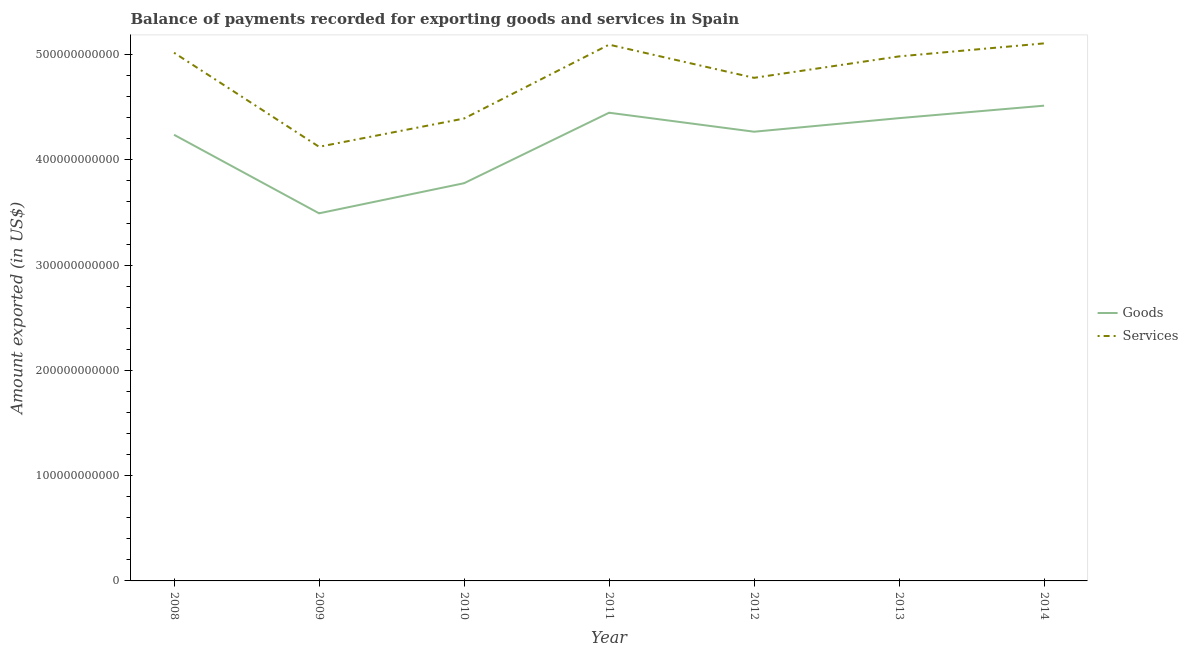Does the line corresponding to amount of services exported intersect with the line corresponding to amount of goods exported?
Your answer should be compact. No. Is the number of lines equal to the number of legend labels?
Give a very brief answer. Yes. What is the amount of goods exported in 2010?
Provide a short and direct response. 3.78e+11. Across all years, what is the maximum amount of services exported?
Provide a short and direct response. 5.11e+11. Across all years, what is the minimum amount of services exported?
Offer a terse response. 4.12e+11. In which year was the amount of services exported maximum?
Your response must be concise. 2014. What is the total amount of services exported in the graph?
Offer a terse response. 3.35e+12. What is the difference between the amount of goods exported in 2011 and that in 2014?
Offer a terse response. -6.69e+09. What is the difference between the amount of services exported in 2014 and the amount of goods exported in 2008?
Your response must be concise. 8.68e+1. What is the average amount of services exported per year?
Provide a succinct answer. 4.79e+11. In the year 2013, what is the difference between the amount of services exported and amount of goods exported?
Keep it short and to the point. 5.87e+1. In how many years, is the amount of services exported greater than 100000000000 US$?
Your answer should be very brief. 7. What is the ratio of the amount of goods exported in 2011 to that in 2012?
Your answer should be very brief. 1.04. Is the difference between the amount of services exported in 2010 and 2011 greater than the difference between the amount of goods exported in 2010 and 2011?
Keep it short and to the point. No. What is the difference between the highest and the second highest amount of goods exported?
Give a very brief answer. 6.69e+09. What is the difference between the highest and the lowest amount of services exported?
Provide a short and direct response. 9.82e+1. Is the sum of the amount of goods exported in 2008 and 2011 greater than the maximum amount of services exported across all years?
Provide a short and direct response. Yes. How many years are there in the graph?
Your answer should be very brief. 7. What is the difference between two consecutive major ticks on the Y-axis?
Your answer should be very brief. 1.00e+11. Does the graph contain any zero values?
Offer a terse response. No. Where does the legend appear in the graph?
Your answer should be compact. Center right. What is the title of the graph?
Your answer should be very brief. Balance of payments recorded for exporting goods and services in Spain. What is the label or title of the X-axis?
Offer a terse response. Year. What is the label or title of the Y-axis?
Provide a short and direct response. Amount exported (in US$). What is the Amount exported (in US$) in Goods in 2008?
Keep it short and to the point. 4.24e+11. What is the Amount exported (in US$) of Services in 2008?
Your response must be concise. 5.02e+11. What is the Amount exported (in US$) in Goods in 2009?
Your answer should be very brief. 3.49e+11. What is the Amount exported (in US$) in Services in 2009?
Keep it short and to the point. 4.12e+11. What is the Amount exported (in US$) of Goods in 2010?
Your response must be concise. 3.78e+11. What is the Amount exported (in US$) of Services in 2010?
Ensure brevity in your answer.  4.39e+11. What is the Amount exported (in US$) in Goods in 2011?
Provide a short and direct response. 4.45e+11. What is the Amount exported (in US$) in Services in 2011?
Your answer should be very brief. 5.09e+11. What is the Amount exported (in US$) of Goods in 2012?
Your answer should be very brief. 4.27e+11. What is the Amount exported (in US$) in Services in 2012?
Offer a terse response. 4.78e+11. What is the Amount exported (in US$) of Goods in 2013?
Make the answer very short. 4.40e+11. What is the Amount exported (in US$) of Services in 2013?
Keep it short and to the point. 4.98e+11. What is the Amount exported (in US$) of Goods in 2014?
Your answer should be compact. 4.52e+11. What is the Amount exported (in US$) of Services in 2014?
Give a very brief answer. 5.11e+11. Across all years, what is the maximum Amount exported (in US$) of Goods?
Provide a short and direct response. 4.52e+11. Across all years, what is the maximum Amount exported (in US$) of Services?
Your answer should be very brief. 5.11e+11. Across all years, what is the minimum Amount exported (in US$) of Goods?
Give a very brief answer. 3.49e+11. Across all years, what is the minimum Amount exported (in US$) in Services?
Your answer should be very brief. 4.12e+11. What is the total Amount exported (in US$) of Goods in the graph?
Ensure brevity in your answer.  2.91e+12. What is the total Amount exported (in US$) of Services in the graph?
Your answer should be very brief. 3.35e+12. What is the difference between the Amount exported (in US$) of Goods in 2008 and that in 2009?
Keep it short and to the point. 7.46e+1. What is the difference between the Amount exported (in US$) in Services in 2008 and that in 2009?
Your answer should be very brief. 8.94e+1. What is the difference between the Amount exported (in US$) in Goods in 2008 and that in 2010?
Give a very brief answer. 4.60e+1. What is the difference between the Amount exported (in US$) of Services in 2008 and that in 2010?
Keep it short and to the point. 6.25e+1. What is the difference between the Amount exported (in US$) of Goods in 2008 and that in 2011?
Offer a very short reply. -2.10e+1. What is the difference between the Amount exported (in US$) in Services in 2008 and that in 2011?
Give a very brief answer. -7.68e+09. What is the difference between the Amount exported (in US$) of Goods in 2008 and that in 2012?
Provide a succinct answer. -2.91e+09. What is the difference between the Amount exported (in US$) of Services in 2008 and that in 2012?
Your response must be concise. 2.39e+1. What is the difference between the Amount exported (in US$) in Goods in 2008 and that in 2013?
Keep it short and to the point. -1.58e+1. What is the difference between the Amount exported (in US$) of Services in 2008 and that in 2013?
Provide a succinct answer. 3.48e+09. What is the difference between the Amount exported (in US$) in Goods in 2008 and that in 2014?
Provide a succinct answer. -2.76e+1. What is the difference between the Amount exported (in US$) in Services in 2008 and that in 2014?
Give a very brief answer. -8.88e+09. What is the difference between the Amount exported (in US$) of Goods in 2009 and that in 2010?
Offer a very short reply. -2.86e+1. What is the difference between the Amount exported (in US$) of Services in 2009 and that in 2010?
Make the answer very short. -2.69e+1. What is the difference between the Amount exported (in US$) of Goods in 2009 and that in 2011?
Give a very brief answer. -9.56e+1. What is the difference between the Amount exported (in US$) in Services in 2009 and that in 2011?
Your answer should be very brief. -9.70e+1. What is the difference between the Amount exported (in US$) in Goods in 2009 and that in 2012?
Give a very brief answer. -7.75e+1. What is the difference between the Amount exported (in US$) of Services in 2009 and that in 2012?
Offer a very short reply. -6.55e+1. What is the difference between the Amount exported (in US$) in Goods in 2009 and that in 2013?
Keep it short and to the point. -9.04e+1. What is the difference between the Amount exported (in US$) in Services in 2009 and that in 2013?
Keep it short and to the point. -8.59e+1. What is the difference between the Amount exported (in US$) in Goods in 2009 and that in 2014?
Your answer should be very brief. -1.02e+11. What is the difference between the Amount exported (in US$) of Services in 2009 and that in 2014?
Offer a terse response. -9.82e+1. What is the difference between the Amount exported (in US$) of Goods in 2010 and that in 2011?
Ensure brevity in your answer.  -6.70e+1. What is the difference between the Amount exported (in US$) of Services in 2010 and that in 2011?
Your response must be concise. -7.02e+1. What is the difference between the Amount exported (in US$) of Goods in 2010 and that in 2012?
Offer a terse response. -4.89e+1. What is the difference between the Amount exported (in US$) of Services in 2010 and that in 2012?
Keep it short and to the point. -3.86e+1. What is the difference between the Amount exported (in US$) of Goods in 2010 and that in 2013?
Your response must be concise. -6.18e+1. What is the difference between the Amount exported (in US$) in Services in 2010 and that in 2013?
Your answer should be compact. -5.90e+1. What is the difference between the Amount exported (in US$) of Goods in 2010 and that in 2014?
Ensure brevity in your answer.  -7.37e+1. What is the difference between the Amount exported (in US$) of Services in 2010 and that in 2014?
Offer a terse response. -7.14e+1. What is the difference between the Amount exported (in US$) of Goods in 2011 and that in 2012?
Make the answer very short. 1.80e+1. What is the difference between the Amount exported (in US$) in Services in 2011 and that in 2012?
Offer a very short reply. 3.15e+1. What is the difference between the Amount exported (in US$) in Goods in 2011 and that in 2013?
Offer a terse response. 5.15e+09. What is the difference between the Amount exported (in US$) of Services in 2011 and that in 2013?
Your answer should be very brief. 1.12e+1. What is the difference between the Amount exported (in US$) in Goods in 2011 and that in 2014?
Provide a succinct answer. -6.69e+09. What is the difference between the Amount exported (in US$) in Services in 2011 and that in 2014?
Your response must be concise. -1.21e+09. What is the difference between the Amount exported (in US$) in Goods in 2012 and that in 2013?
Your answer should be compact. -1.29e+1. What is the difference between the Amount exported (in US$) in Services in 2012 and that in 2013?
Your answer should be very brief. -2.04e+1. What is the difference between the Amount exported (in US$) of Goods in 2012 and that in 2014?
Give a very brief answer. -2.47e+1. What is the difference between the Amount exported (in US$) of Services in 2012 and that in 2014?
Your answer should be compact. -3.27e+1. What is the difference between the Amount exported (in US$) in Goods in 2013 and that in 2014?
Offer a very short reply. -1.18e+1. What is the difference between the Amount exported (in US$) in Services in 2013 and that in 2014?
Your answer should be compact. -1.24e+1. What is the difference between the Amount exported (in US$) in Goods in 2008 and the Amount exported (in US$) in Services in 2009?
Your answer should be compact. 1.14e+1. What is the difference between the Amount exported (in US$) in Goods in 2008 and the Amount exported (in US$) in Services in 2010?
Your answer should be compact. -1.54e+1. What is the difference between the Amount exported (in US$) of Goods in 2008 and the Amount exported (in US$) of Services in 2011?
Keep it short and to the point. -8.56e+1. What is the difference between the Amount exported (in US$) in Goods in 2008 and the Amount exported (in US$) in Services in 2012?
Make the answer very short. -5.41e+1. What is the difference between the Amount exported (in US$) in Goods in 2008 and the Amount exported (in US$) in Services in 2013?
Your answer should be compact. -7.45e+1. What is the difference between the Amount exported (in US$) in Goods in 2008 and the Amount exported (in US$) in Services in 2014?
Make the answer very short. -8.68e+1. What is the difference between the Amount exported (in US$) in Goods in 2009 and the Amount exported (in US$) in Services in 2010?
Give a very brief answer. -9.01e+1. What is the difference between the Amount exported (in US$) of Goods in 2009 and the Amount exported (in US$) of Services in 2011?
Keep it short and to the point. -1.60e+11. What is the difference between the Amount exported (in US$) in Goods in 2009 and the Amount exported (in US$) in Services in 2012?
Provide a short and direct response. -1.29e+11. What is the difference between the Amount exported (in US$) of Goods in 2009 and the Amount exported (in US$) of Services in 2013?
Provide a succinct answer. -1.49e+11. What is the difference between the Amount exported (in US$) of Goods in 2009 and the Amount exported (in US$) of Services in 2014?
Your answer should be compact. -1.61e+11. What is the difference between the Amount exported (in US$) of Goods in 2010 and the Amount exported (in US$) of Services in 2011?
Keep it short and to the point. -1.32e+11. What is the difference between the Amount exported (in US$) in Goods in 2010 and the Amount exported (in US$) in Services in 2012?
Provide a succinct answer. -1.00e+11. What is the difference between the Amount exported (in US$) in Goods in 2010 and the Amount exported (in US$) in Services in 2013?
Your response must be concise. -1.20e+11. What is the difference between the Amount exported (in US$) of Goods in 2010 and the Amount exported (in US$) of Services in 2014?
Your answer should be very brief. -1.33e+11. What is the difference between the Amount exported (in US$) of Goods in 2011 and the Amount exported (in US$) of Services in 2012?
Ensure brevity in your answer.  -3.31e+1. What is the difference between the Amount exported (in US$) of Goods in 2011 and the Amount exported (in US$) of Services in 2013?
Your answer should be compact. -5.35e+1. What is the difference between the Amount exported (in US$) in Goods in 2011 and the Amount exported (in US$) in Services in 2014?
Make the answer very short. -6.59e+1. What is the difference between the Amount exported (in US$) of Goods in 2012 and the Amount exported (in US$) of Services in 2013?
Your answer should be very brief. -7.16e+1. What is the difference between the Amount exported (in US$) in Goods in 2012 and the Amount exported (in US$) in Services in 2014?
Your response must be concise. -8.39e+1. What is the difference between the Amount exported (in US$) of Goods in 2013 and the Amount exported (in US$) of Services in 2014?
Give a very brief answer. -7.10e+1. What is the average Amount exported (in US$) in Goods per year?
Offer a terse response. 4.16e+11. What is the average Amount exported (in US$) of Services per year?
Give a very brief answer. 4.79e+11. In the year 2008, what is the difference between the Amount exported (in US$) in Goods and Amount exported (in US$) in Services?
Make the answer very short. -7.80e+1. In the year 2009, what is the difference between the Amount exported (in US$) of Goods and Amount exported (in US$) of Services?
Keep it short and to the point. -6.32e+1. In the year 2010, what is the difference between the Amount exported (in US$) in Goods and Amount exported (in US$) in Services?
Ensure brevity in your answer.  -6.15e+1. In the year 2011, what is the difference between the Amount exported (in US$) in Goods and Amount exported (in US$) in Services?
Keep it short and to the point. -6.47e+1. In the year 2012, what is the difference between the Amount exported (in US$) in Goods and Amount exported (in US$) in Services?
Your answer should be compact. -5.12e+1. In the year 2013, what is the difference between the Amount exported (in US$) in Goods and Amount exported (in US$) in Services?
Your answer should be compact. -5.87e+1. In the year 2014, what is the difference between the Amount exported (in US$) of Goods and Amount exported (in US$) of Services?
Your answer should be very brief. -5.92e+1. What is the ratio of the Amount exported (in US$) in Goods in 2008 to that in 2009?
Offer a very short reply. 1.21. What is the ratio of the Amount exported (in US$) of Services in 2008 to that in 2009?
Your answer should be compact. 1.22. What is the ratio of the Amount exported (in US$) of Goods in 2008 to that in 2010?
Your response must be concise. 1.12. What is the ratio of the Amount exported (in US$) in Services in 2008 to that in 2010?
Your response must be concise. 1.14. What is the ratio of the Amount exported (in US$) in Goods in 2008 to that in 2011?
Your response must be concise. 0.95. What is the ratio of the Amount exported (in US$) in Services in 2008 to that in 2011?
Your answer should be very brief. 0.98. What is the ratio of the Amount exported (in US$) in Goods in 2008 to that in 2012?
Your answer should be very brief. 0.99. What is the ratio of the Amount exported (in US$) in Services in 2008 to that in 2012?
Provide a short and direct response. 1.05. What is the ratio of the Amount exported (in US$) in Goods in 2008 to that in 2013?
Offer a very short reply. 0.96. What is the ratio of the Amount exported (in US$) in Services in 2008 to that in 2013?
Offer a very short reply. 1.01. What is the ratio of the Amount exported (in US$) of Goods in 2008 to that in 2014?
Make the answer very short. 0.94. What is the ratio of the Amount exported (in US$) in Services in 2008 to that in 2014?
Keep it short and to the point. 0.98. What is the ratio of the Amount exported (in US$) in Goods in 2009 to that in 2010?
Your answer should be very brief. 0.92. What is the ratio of the Amount exported (in US$) in Services in 2009 to that in 2010?
Give a very brief answer. 0.94. What is the ratio of the Amount exported (in US$) of Goods in 2009 to that in 2011?
Provide a short and direct response. 0.79. What is the ratio of the Amount exported (in US$) in Services in 2009 to that in 2011?
Keep it short and to the point. 0.81. What is the ratio of the Amount exported (in US$) in Goods in 2009 to that in 2012?
Provide a short and direct response. 0.82. What is the ratio of the Amount exported (in US$) of Services in 2009 to that in 2012?
Your answer should be compact. 0.86. What is the ratio of the Amount exported (in US$) in Goods in 2009 to that in 2013?
Your answer should be very brief. 0.79. What is the ratio of the Amount exported (in US$) of Services in 2009 to that in 2013?
Offer a terse response. 0.83. What is the ratio of the Amount exported (in US$) in Goods in 2009 to that in 2014?
Provide a succinct answer. 0.77. What is the ratio of the Amount exported (in US$) of Services in 2009 to that in 2014?
Keep it short and to the point. 0.81. What is the ratio of the Amount exported (in US$) in Goods in 2010 to that in 2011?
Provide a succinct answer. 0.85. What is the ratio of the Amount exported (in US$) of Services in 2010 to that in 2011?
Keep it short and to the point. 0.86. What is the ratio of the Amount exported (in US$) of Goods in 2010 to that in 2012?
Your response must be concise. 0.89. What is the ratio of the Amount exported (in US$) in Services in 2010 to that in 2012?
Give a very brief answer. 0.92. What is the ratio of the Amount exported (in US$) in Goods in 2010 to that in 2013?
Offer a terse response. 0.86. What is the ratio of the Amount exported (in US$) of Services in 2010 to that in 2013?
Your response must be concise. 0.88. What is the ratio of the Amount exported (in US$) in Goods in 2010 to that in 2014?
Provide a succinct answer. 0.84. What is the ratio of the Amount exported (in US$) in Services in 2010 to that in 2014?
Ensure brevity in your answer.  0.86. What is the ratio of the Amount exported (in US$) of Goods in 2011 to that in 2012?
Your answer should be compact. 1.04. What is the ratio of the Amount exported (in US$) of Services in 2011 to that in 2012?
Make the answer very short. 1.07. What is the ratio of the Amount exported (in US$) in Goods in 2011 to that in 2013?
Your answer should be very brief. 1.01. What is the ratio of the Amount exported (in US$) of Services in 2011 to that in 2013?
Give a very brief answer. 1.02. What is the ratio of the Amount exported (in US$) of Goods in 2011 to that in 2014?
Offer a terse response. 0.99. What is the ratio of the Amount exported (in US$) of Services in 2011 to that in 2014?
Provide a short and direct response. 1. What is the ratio of the Amount exported (in US$) in Goods in 2012 to that in 2013?
Provide a succinct answer. 0.97. What is the ratio of the Amount exported (in US$) of Services in 2012 to that in 2013?
Provide a short and direct response. 0.96. What is the ratio of the Amount exported (in US$) in Goods in 2012 to that in 2014?
Give a very brief answer. 0.95. What is the ratio of the Amount exported (in US$) of Services in 2012 to that in 2014?
Keep it short and to the point. 0.94. What is the ratio of the Amount exported (in US$) of Goods in 2013 to that in 2014?
Provide a succinct answer. 0.97. What is the ratio of the Amount exported (in US$) in Services in 2013 to that in 2014?
Your answer should be very brief. 0.98. What is the difference between the highest and the second highest Amount exported (in US$) in Goods?
Keep it short and to the point. 6.69e+09. What is the difference between the highest and the second highest Amount exported (in US$) of Services?
Your answer should be compact. 1.21e+09. What is the difference between the highest and the lowest Amount exported (in US$) of Goods?
Offer a very short reply. 1.02e+11. What is the difference between the highest and the lowest Amount exported (in US$) in Services?
Provide a succinct answer. 9.82e+1. 